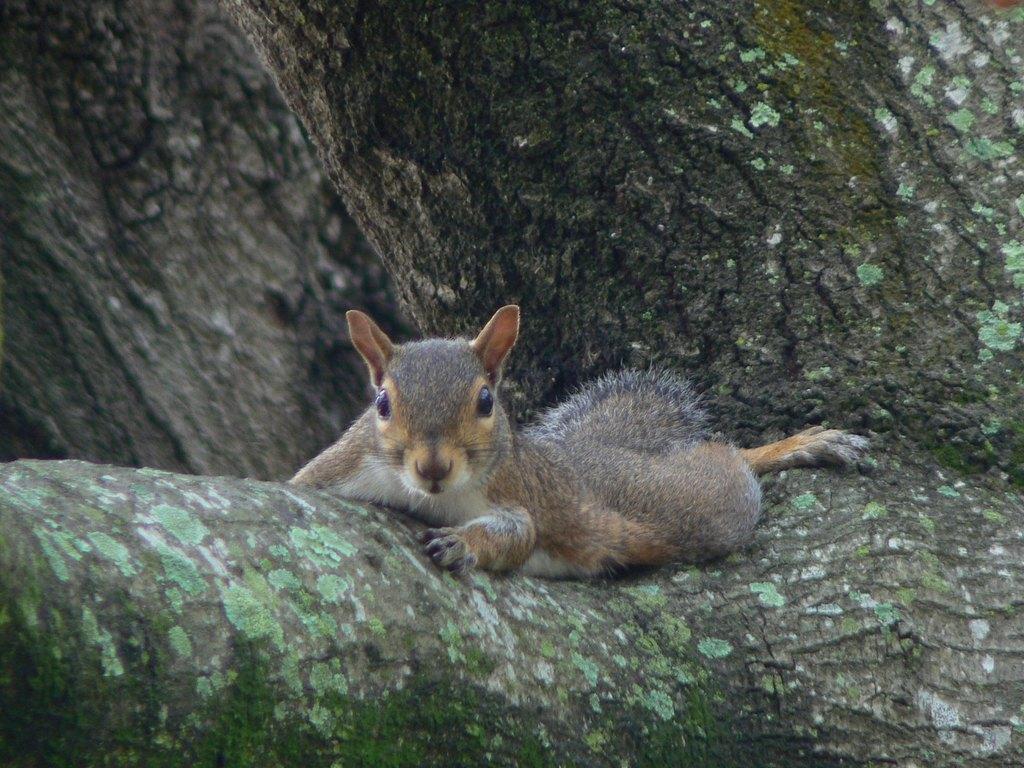How would you summarize this image in a sentence or two? There is a squirrel laying on the branch of a tree. In the background, there is a tree. 